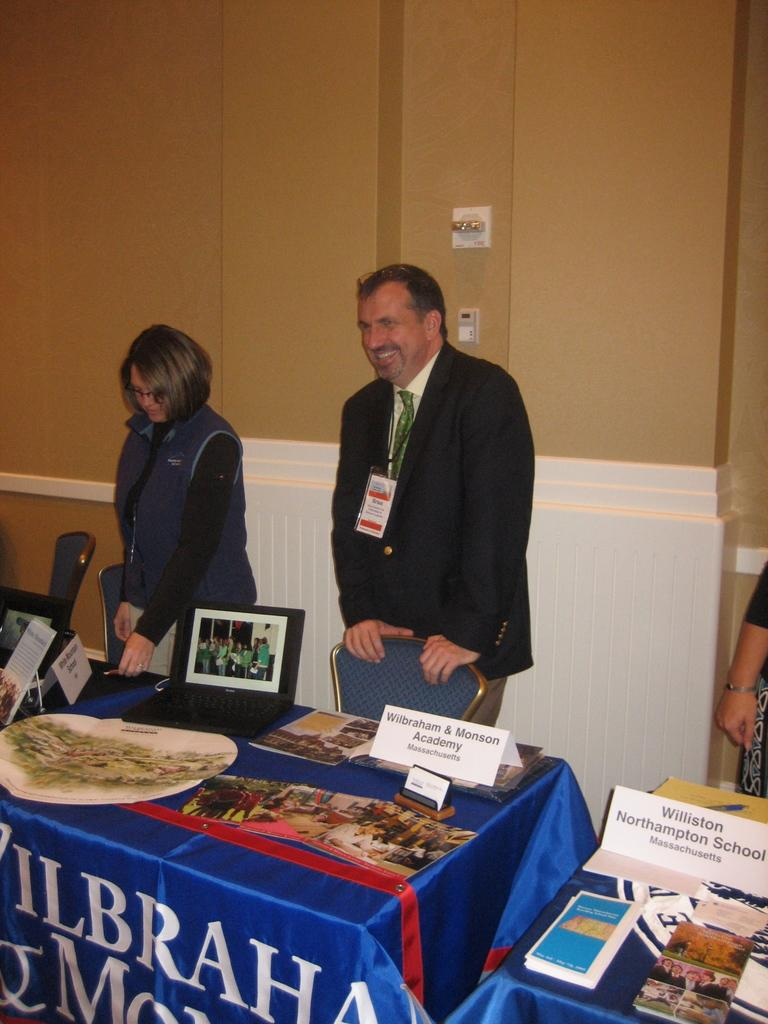Provide a one-sentence caption for the provided image. Man and woman standing in front of a chair for Wilbraham and Monson Academy. 